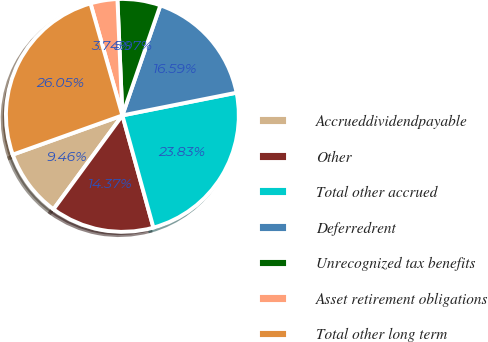<chart> <loc_0><loc_0><loc_500><loc_500><pie_chart><fcel>Accrueddividendpayable<fcel>Other<fcel>Total other accrued<fcel>Deferredrent<fcel>Unrecognized tax benefits<fcel>Asset retirement obligations<fcel>Total other long term<nl><fcel>9.46%<fcel>14.37%<fcel>23.83%<fcel>16.59%<fcel>5.97%<fcel>3.74%<fcel>26.05%<nl></chart> 